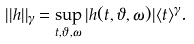Convert formula to latex. <formula><loc_0><loc_0><loc_500><loc_500>| | h | | _ { \gamma } = \sup _ { t , \vartheta , \omega } | h ( t , \vartheta , \omega ) | \langle t \rangle ^ { \gamma } .</formula> 